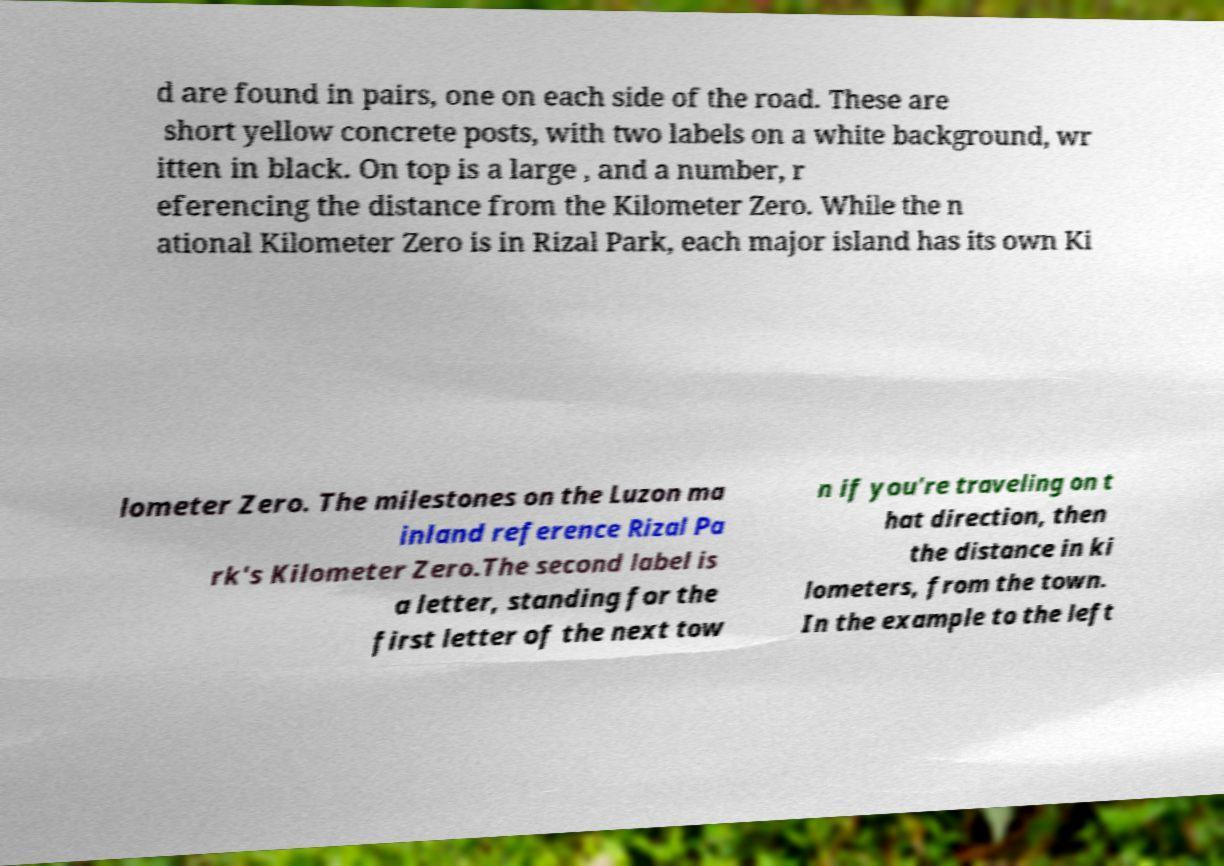Could you assist in decoding the text presented in this image and type it out clearly? d are found in pairs, one on each side of the road. These are short yellow concrete posts, with two labels on a white background, wr itten in black. On top is a large , and a number, r eferencing the distance from the Kilometer Zero. While the n ational Kilometer Zero is in Rizal Park, each major island has its own Ki lometer Zero. The milestones on the Luzon ma inland reference Rizal Pa rk's Kilometer Zero.The second label is a letter, standing for the first letter of the next tow n if you're traveling on t hat direction, then the distance in ki lometers, from the town. In the example to the left 